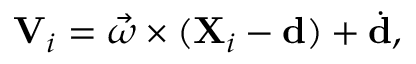<formula> <loc_0><loc_0><loc_500><loc_500>V _ { i } = { \vec { \omega } } \times ( X _ { i } - d ) + { \dot { d } } ,</formula> 